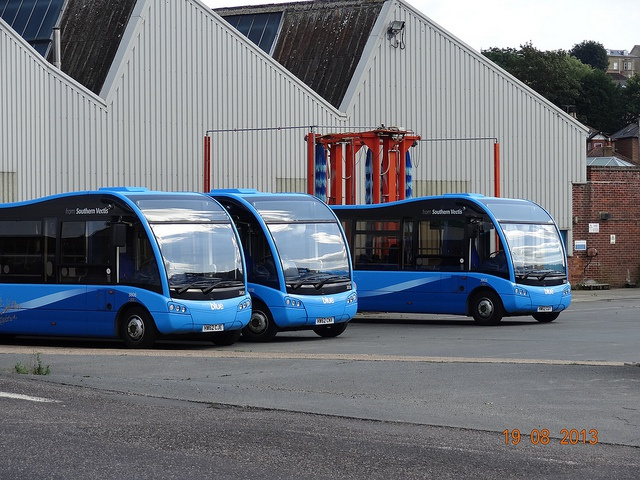Describe the objects in this image and their specific colors. I can see bus in black, navy, blue, and darkgray tones, bus in black, navy, blue, and lightblue tones, and bus in black, darkgray, and blue tones in this image. 